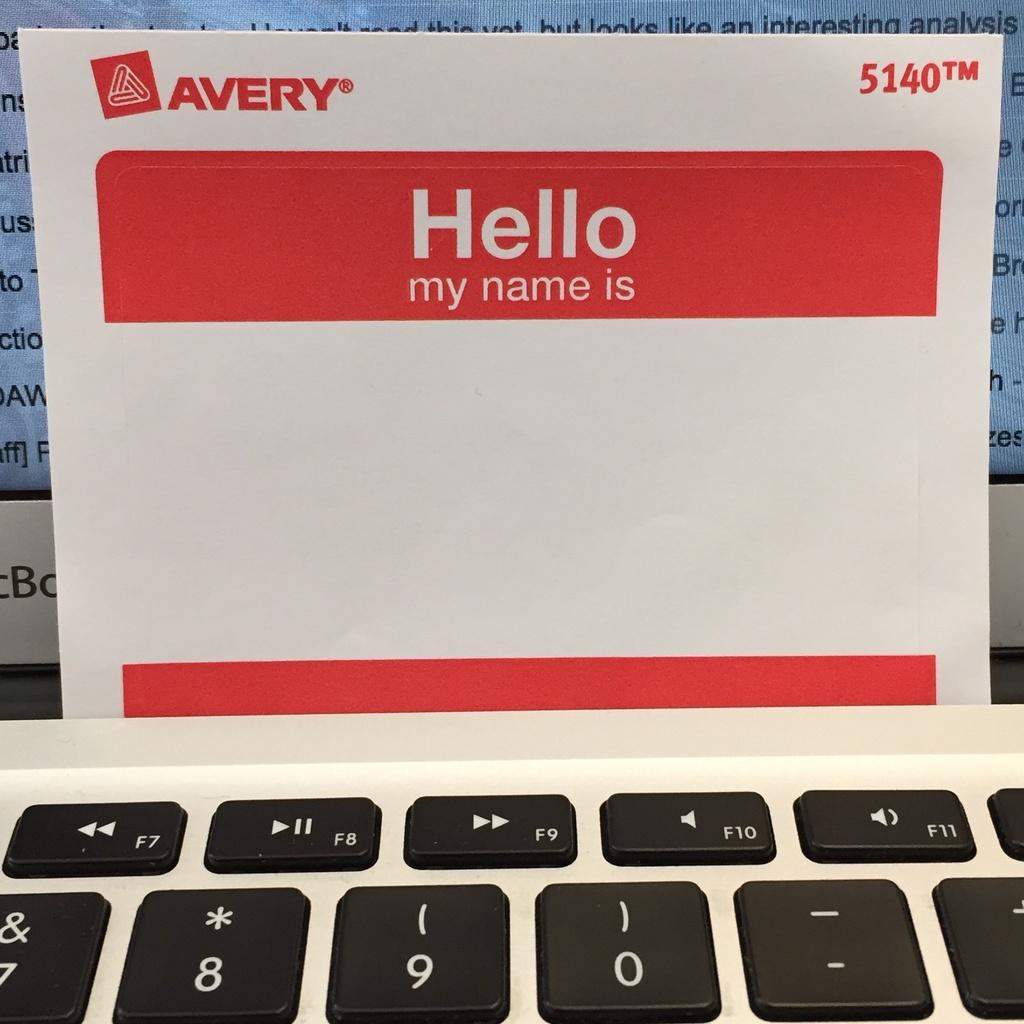<image>
Share a concise interpretation of the image provided. A blank avery sticky back name tag with red borders. 